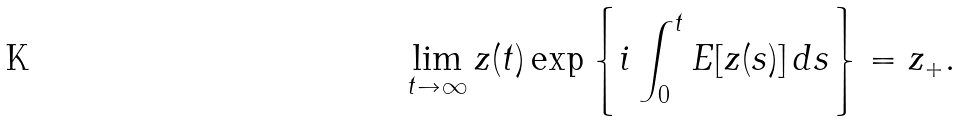<formula> <loc_0><loc_0><loc_500><loc_500>\lim _ { t \to \infty } z ( t ) \exp \left \{ i \int _ { 0 } ^ { t } E [ z ( s ) ] \, d s \right \} = z _ { + } .</formula> 